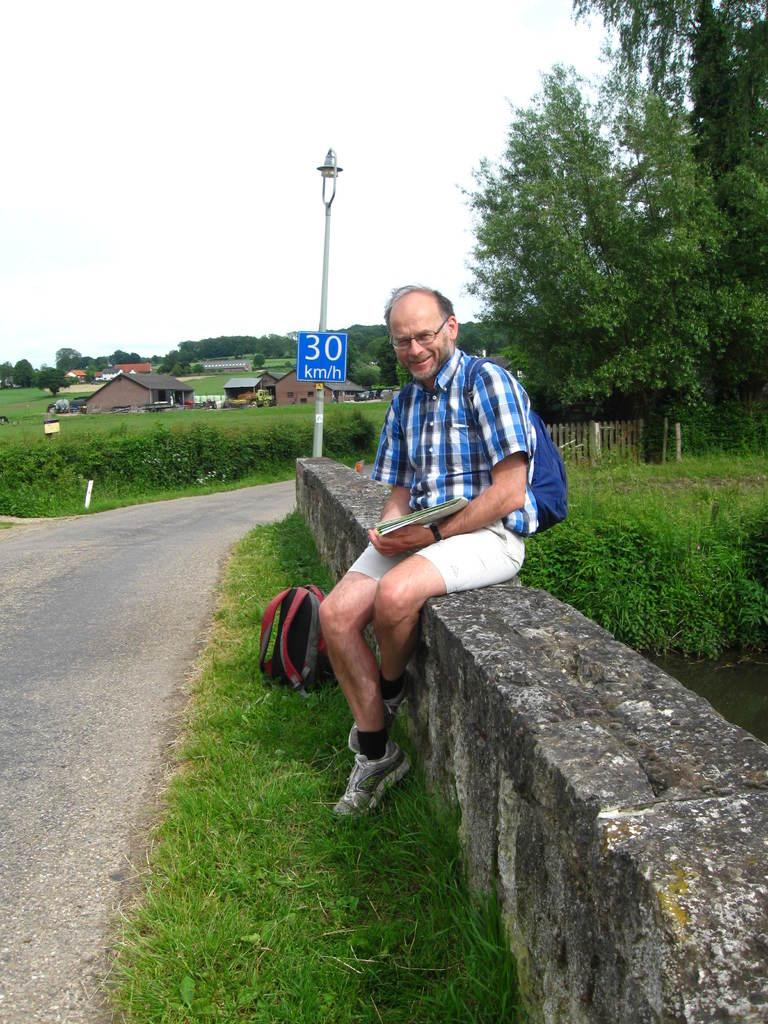<image>
Provide a brief description of the given image. a man next to a sign with 30 on it 